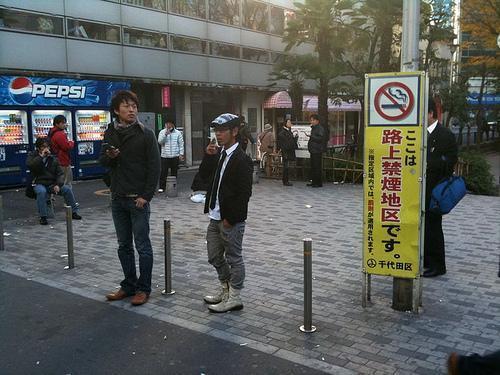How many people are on cell phones?
Give a very brief answer. 2. How many people are sitting?
Give a very brief answer. 1. How many people can you see?
Give a very brief answer. 3. 